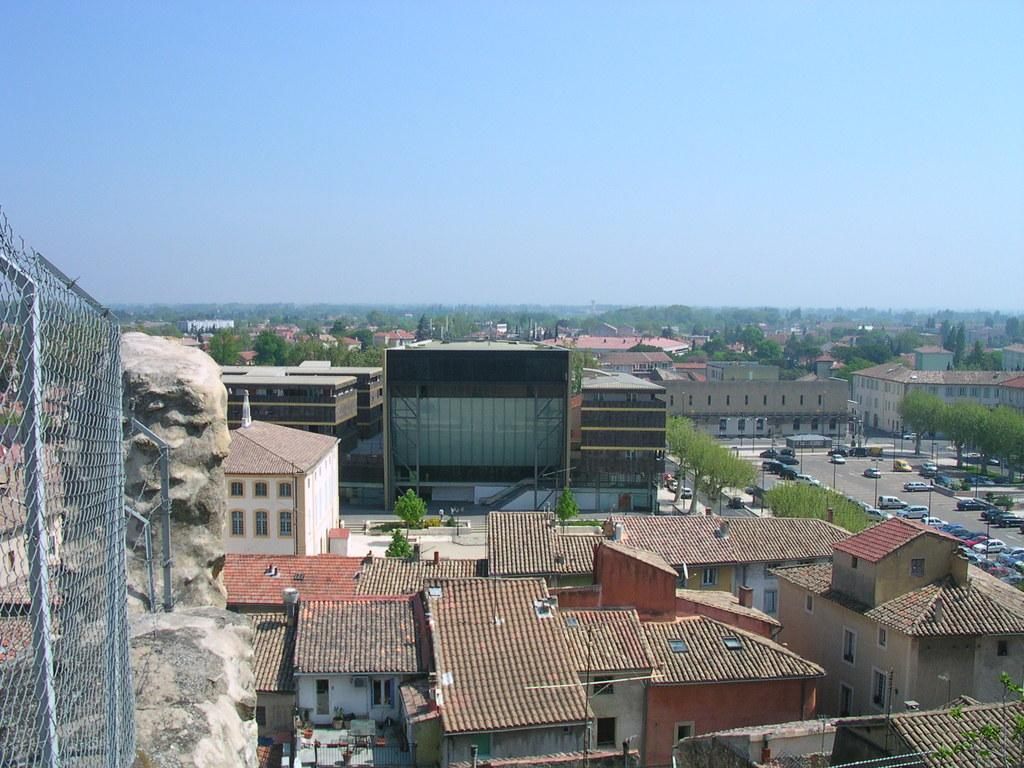What type of structures can be seen in the image? There are buildings in the image. What other natural elements are present in the image? There are trees in the image. What mode of transportation can be seen on the road in the image? There are vehicles on the road in the image. What type of barrier is present in the image? There is a fence in the image. What small object can be found in the image? There is a stone in the image. What type of small mammals are present in the image? Some moles are present in the image. What type of bell can be heard ringing in the image? There is no bell present in the image, and therefore no sound can be heard. Can you tell me how many planes are flying in the image? There are no planes visible in the image. What type of profit can be seen being made by the moles in the image? The image does not depict any profit being made by the moles, as they are small mammals and not involved in financial transactions. 